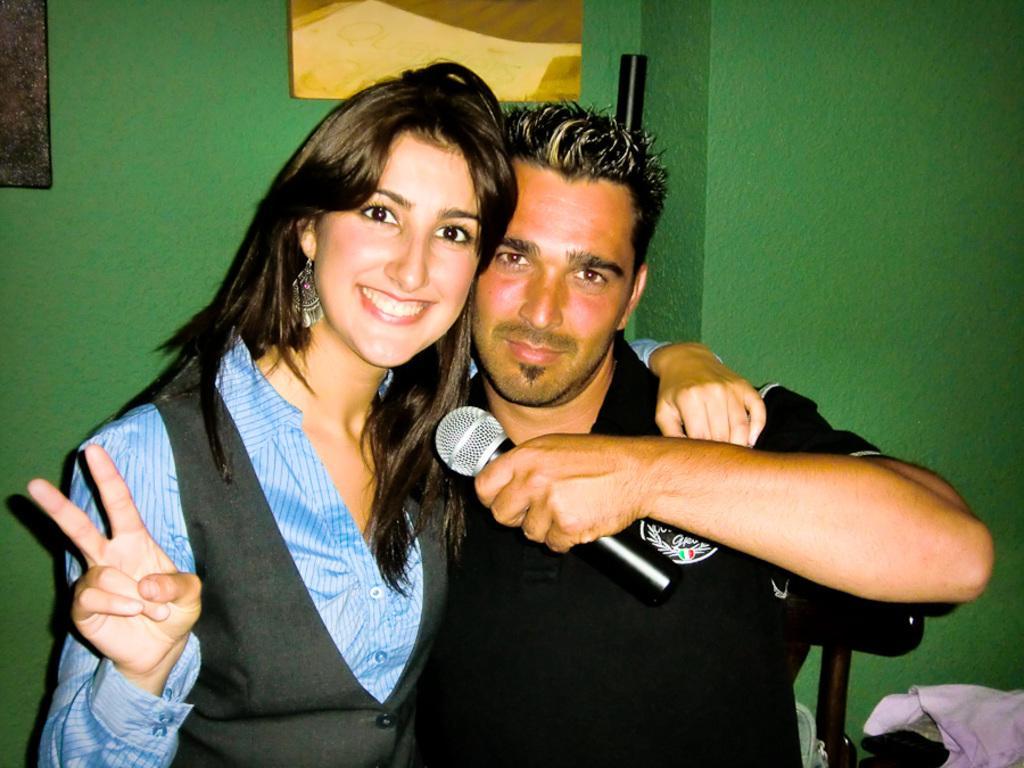How would you summarize this image in a sentence or two? In the image there is a man holding mic and beside there is a woman smiling. 